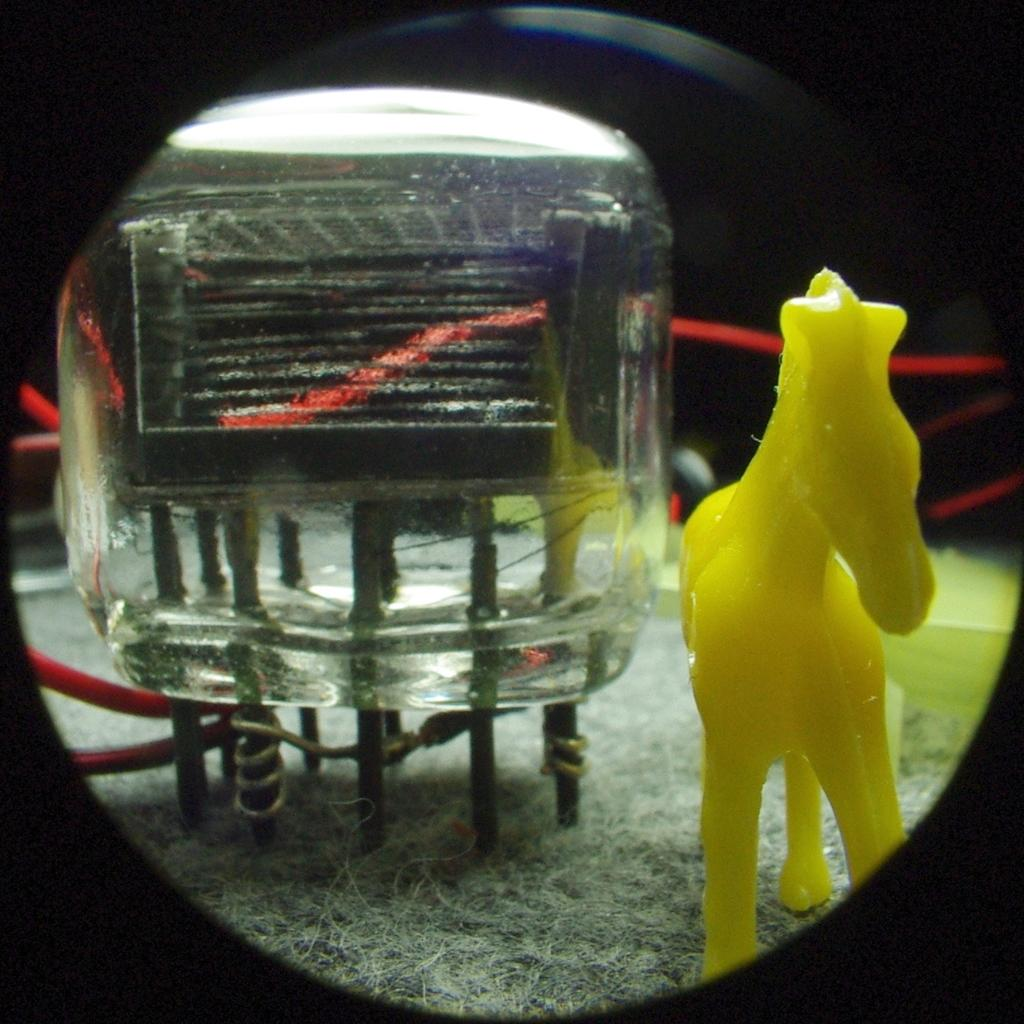What is the main subject in the image? There is a statue in the image. What other object can be seen in the image? There is an object in the shape of glass in the image. Can you describe the background of the image? There are red wires in the background of the image. How many passengers are visible in the image? There are no passengers present in the image; it features a statue and a glass-shaped object with red wires in the background. 